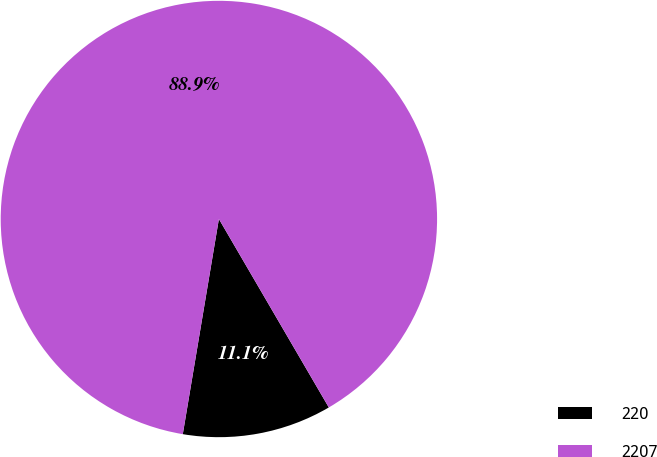<chart> <loc_0><loc_0><loc_500><loc_500><pie_chart><fcel>220<fcel>2207<nl><fcel>11.05%<fcel>88.95%<nl></chart> 